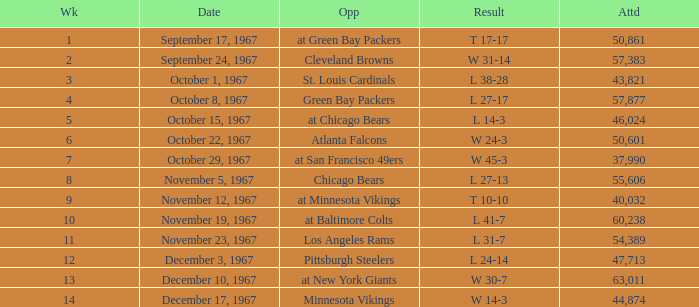Which Result has an Opponent of minnesota vikings? W 14-3. 